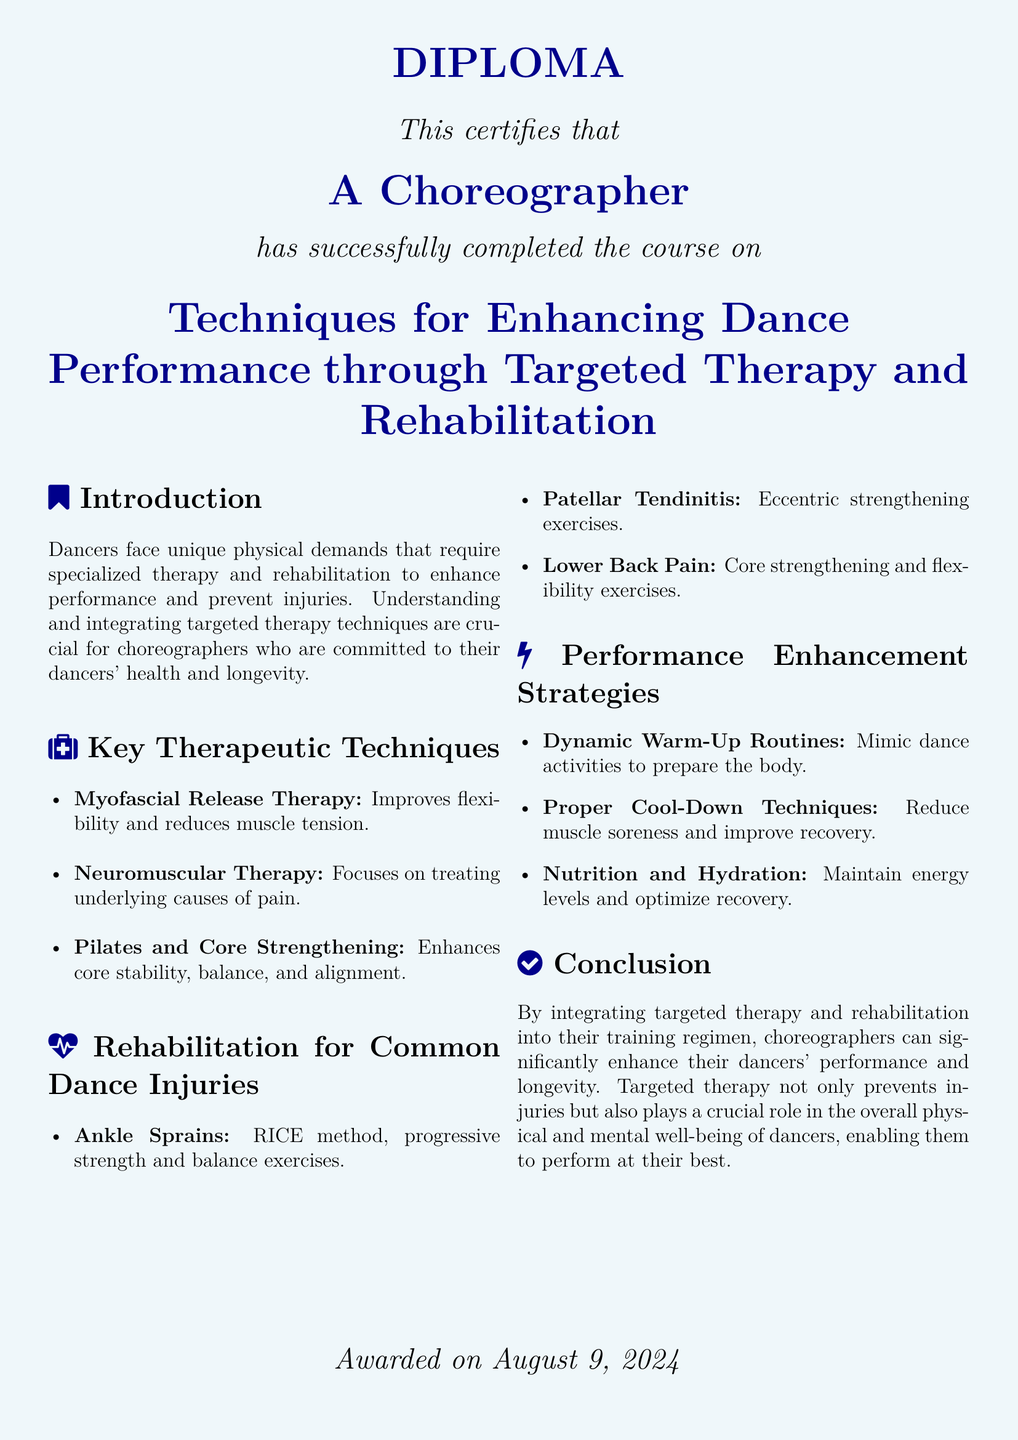What is the title of the course? The title of the course is stated in the document, focusing on techniques for dance performance enhancement through therapy and rehabilitation.
Answer: Techniques for Enhancing Dance Performance through Targeted Therapy and Rehabilitation Who completed the course? The document specifies who has successfully completed the course, which is a choreographer.
Answer: A Choreographer What therapy improves flexibility? The document lists various therapeutic techniques, one of which specifically aims to improve flexibility.
Answer: Myofascial Release Therapy What is the RICE method used for? The RICE method is mentioned in the context of rehabilitation for a specific injury faced by dancers.
Answer: Ankle Sprains Which exercise type is beneficial for lower back pain? The document identifies a type of exercise that is recommended for addressing lower back pain issues.
Answer: Core strengthening and flexibility exercises What is a performance enhancement strategy mentioned? The document outlines various strategies for enhancing performance, specifically mentioning one related to preparing the body.
Answer: Dynamic Warm-Up Routines What is emphasized for dancers' health? The conclusion of the document highlights the importance of a particular approach for enhancing dancers' health and performance.
Answer: Targeted therapy and rehabilitation When was the diploma awarded? The document contains a specific date information regarding the awarding of the diploma.
Answer: today 